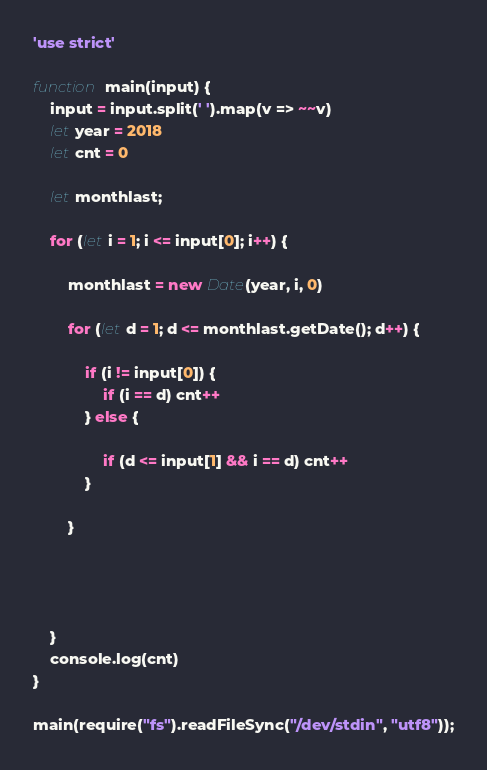Convert code to text. <code><loc_0><loc_0><loc_500><loc_500><_JavaScript_>'use strict'

function main(input) {
    input = input.split(' ').map(v => ~~v)
    let year = 2018
    let cnt = 0

    let monthlast;

    for (let i = 1; i <= input[0]; i++) {

        monthlast = new Date(year, i, 0)

        for (let d = 1; d <= monthlast.getDate(); d++) {

            if (i != input[0]) {
                if (i == d) cnt++
            } else {

                if (d <= input[1] && i == d) cnt++
            }

        }




    }
    console.log(cnt)
}

main(require("fs").readFileSync("/dev/stdin", "utf8"));</code> 